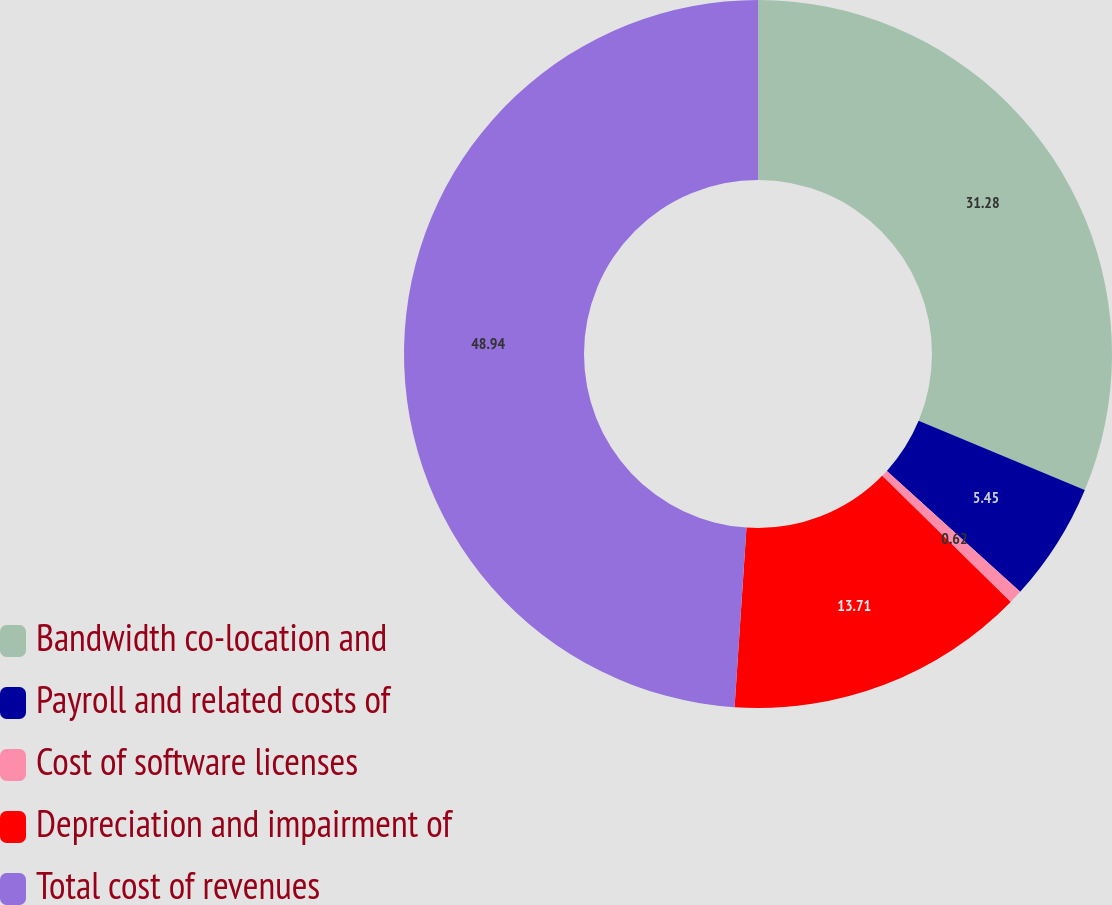Convert chart to OTSL. <chart><loc_0><loc_0><loc_500><loc_500><pie_chart><fcel>Bandwidth co-location and<fcel>Payroll and related costs of<fcel>Cost of software licenses<fcel>Depreciation and impairment of<fcel>Total cost of revenues<nl><fcel>31.28%<fcel>5.45%<fcel>0.62%<fcel>13.71%<fcel>48.95%<nl></chart> 